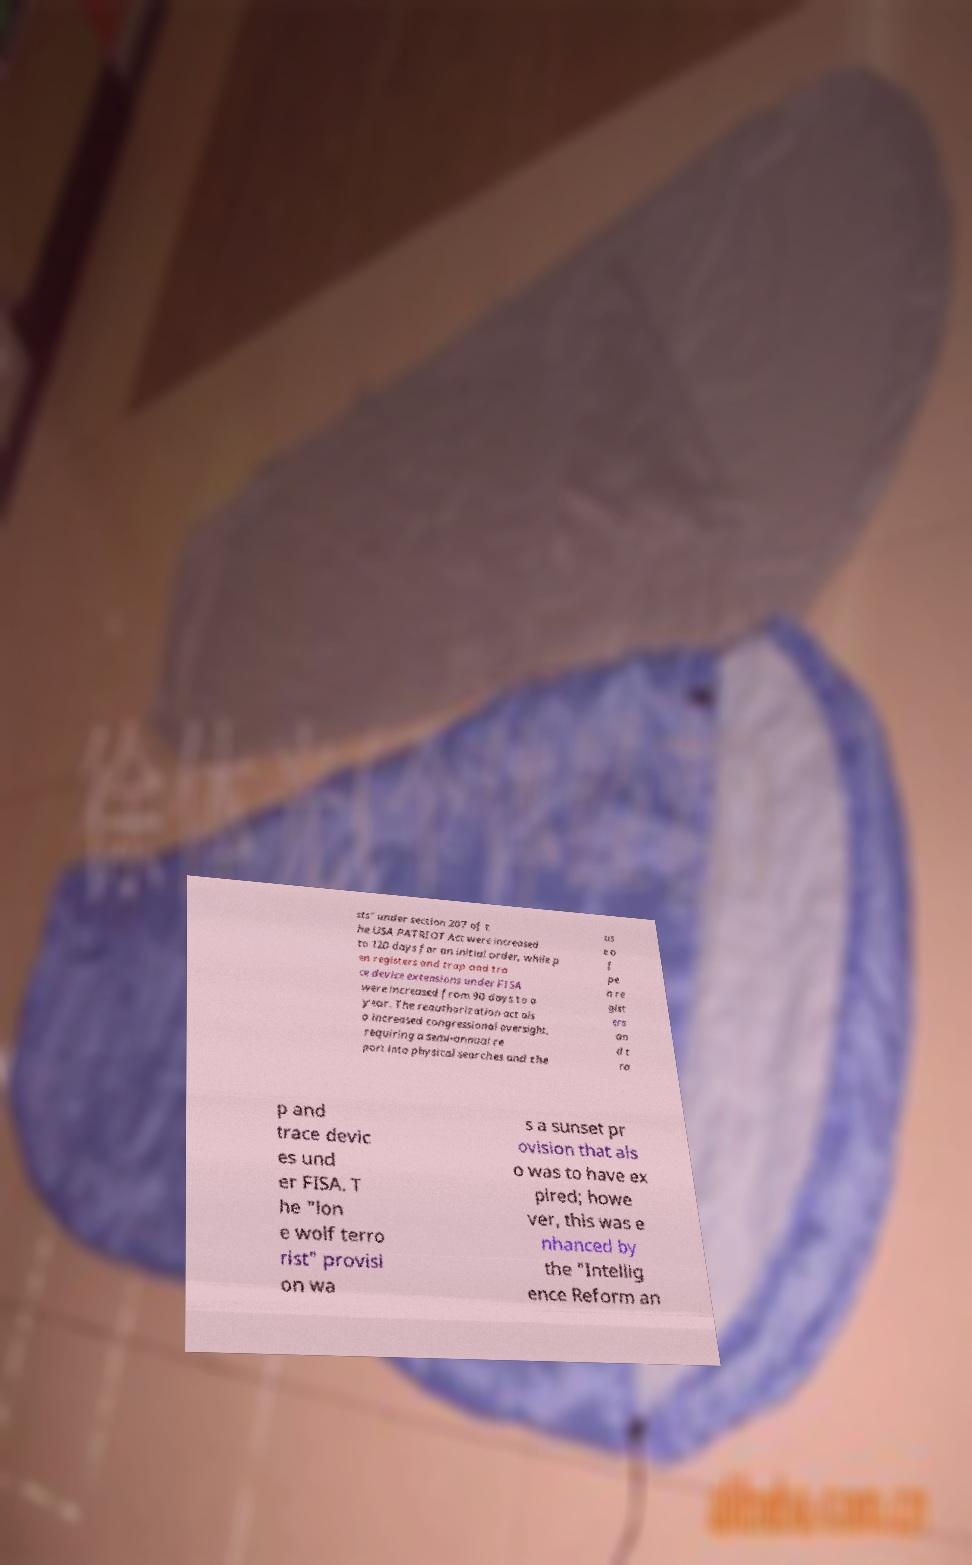Please read and relay the text visible in this image. What does it say? sts" under section 207 of t he USA PATRIOT Act were increased to 120 days for an initial order, while p en registers and trap and tra ce device extensions under FISA were increased from 90 days to a year. The reauthorization act als o increased congressional oversight, requiring a semi-annual re port into physical searches and the us e o f pe n re gist ers an d t ra p and trace devic es und er FISA. T he "lon e wolf terro rist" provisi on wa s a sunset pr ovision that als o was to have ex pired; howe ver, this was e nhanced by the "Intellig ence Reform an 